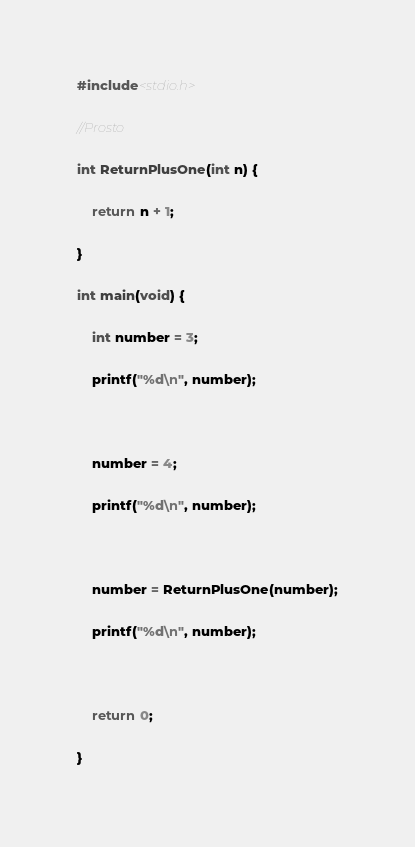Convert code to text. <code><loc_0><loc_0><loc_500><loc_500><_C++_>#include<stdio.h>

//Prosto

int ReturnPlusOne(int n) {

	return n + 1;

}

int main(void) {

	int number = 3;

	printf("%d\n", number);



	number = 4;

	printf("%d\n", number);



	number = ReturnPlusOne(number);

	printf("%d\n", number);



	return 0;

}
</code> 